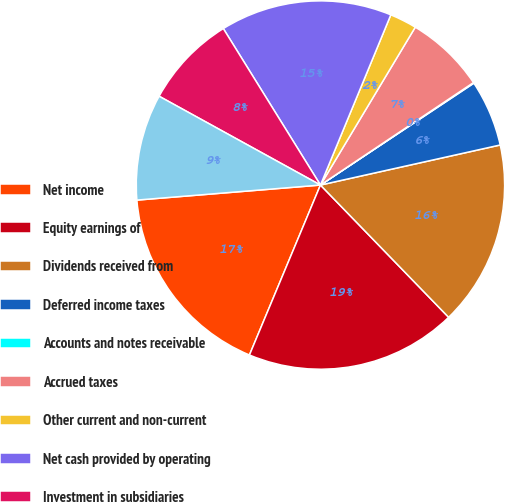Convert chart. <chart><loc_0><loc_0><loc_500><loc_500><pie_chart><fcel>Net income<fcel>Equity earnings of<fcel>Dividends received from<fcel>Deferred income taxes<fcel>Accounts and notes receivable<fcel>Accrued taxes<fcel>Other current and non-current<fcel>Net cash provided by operating<fcel>Investment in subsidiaries<fcel>Net cash used in investing<nl><fcel>17.4%<fcel>18.55%<fcel>16.24%<fcel>5.84%<fcel>0.06%<fcel>7.0%<fcel>2.37%<fcel>15.08%<fcel>8.15%<fcel>9.31%<nl></chart> 